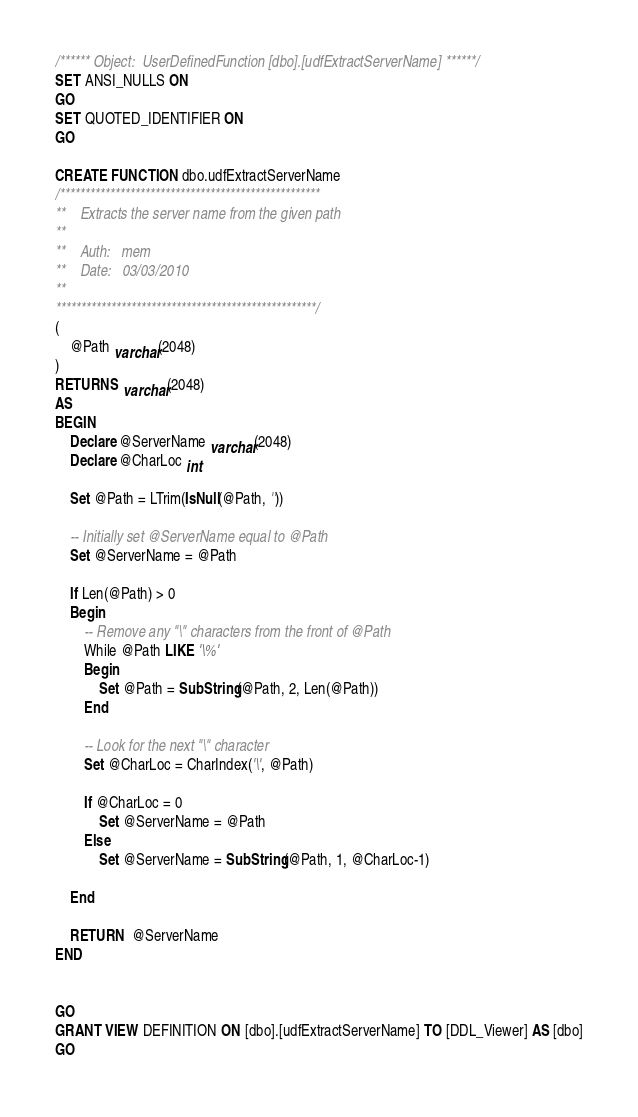<code> <loc_0><loc_0><loc_500><loc_500><_SQL_>/****** Object:  UserDefinedFunction [dbo].[udfExtractServerName] ******/
SET ANSI_NULLS ON
GO
SET QUOTED_IDENTIFIER ON
GO

CREATE FUNCTION dbo.udfExtractServerName
/****************************************************	
**	Extracts the server name from the given path
**
**	Auth:	mem
**	Date:	03/03/2010
**  
****************************************************/
(
	@Path varchar(2048)
)
RETURNS varchar(2048)
AS
BEGIN
	Declare @ServerName varchar(2048)
	Declare @CharLoc int
	
	Set @Path = LTrim(IsNull(@Path, ''))

	-- Initially set @ServerName equal to @Path	
	Set @ServerName = @Path
	
	If Len(@Path) > 0
	Begin
		-- Remove any "\" characters from the front of @Path
		While @Path LIKE '\%'
		Begin
			Set @Path = SubString(@Path, 2, Len(@Path))
		End

		-- Look for the next "\" character
		Set @CharLoc = CharIndex('\', @Path)
		
		If @CharLoc = 0
			Set @ServerName = @Path
		Else
			Set @ServerName = SubString(@Path, 1, @CharLoc-1)

	End
	
	RETURN  @ServerName
END


GO
GRANT VIEW DEFINITION ON [dbo].[udfExtractServerName] TO [DDL_Viewer] AS [dbo]
GO
</code> 